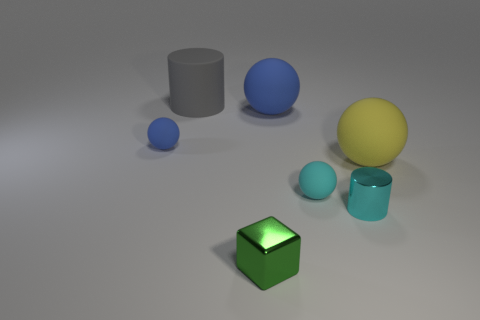Subtract 3 balls. How many balls are left? 1 Add 7 large cylinders. How many large cylinders are left? 8 Add 6 tiny blue balls. How many tiny blue balls exist? 7 Add 2 tiny blue metallic cubes. How many objects exist? 9 Subtract all yellow balls. How many balls are left? 3 Subtract all yellow spheres. How many spheres are left? 3 Subtract 0 green spheres. How many objects are left? 7 Subtract all cylinders. How many objects are left? 5 Subtract all blue blocks. Subtract all brown cylinders. How many blocks are left? 1 Subtract all brown cubes. How many gray cylinders are left? 1 